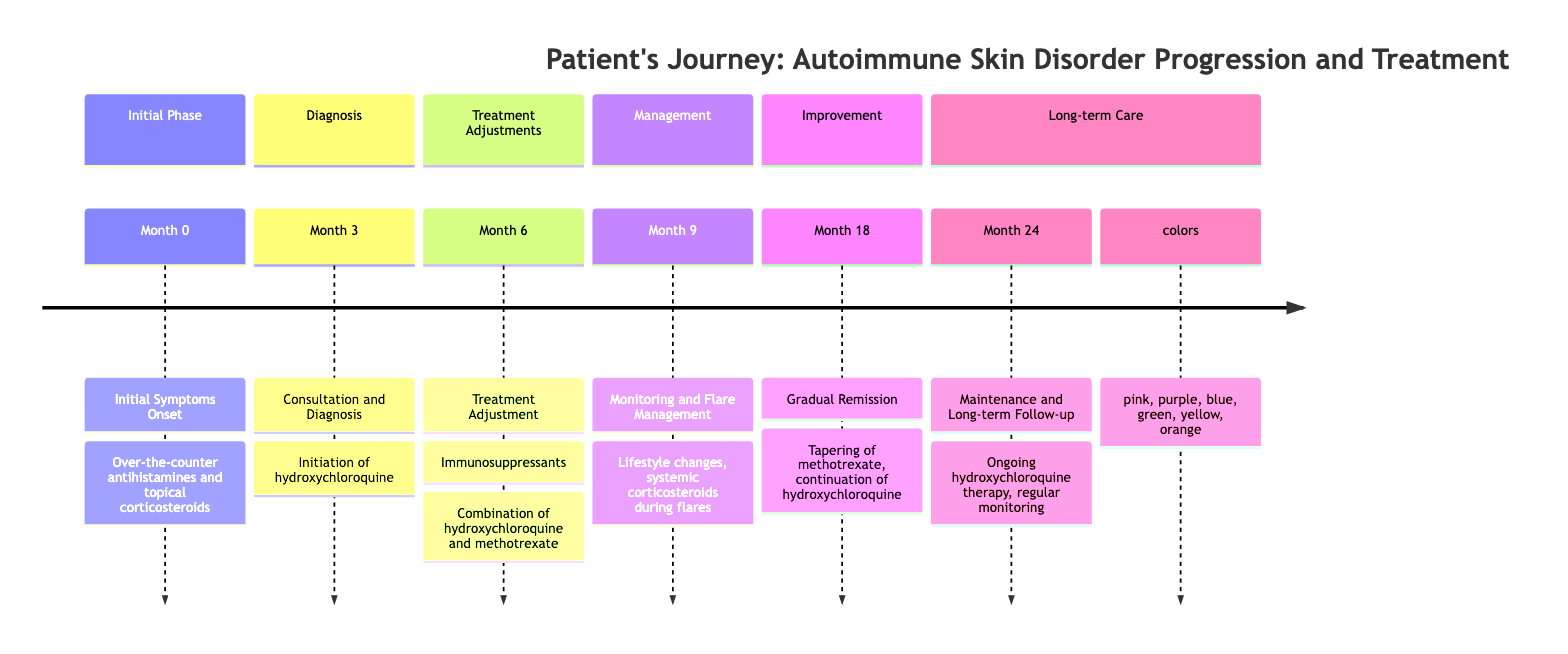What is the initial treatment for the patient? The patient initially received over-the-counter antihistamines and topical corticosteroids for symptom relief at the onset of symptoms. This information is mentioned in the "Initial Symptoms Onset" phase.
Answer: Over-the-counter antihistamines and topical corticosteroids How many months did it take for the patient to receive a diagnosis? The timeline indicates that the diagnosis occurred at Month 3, following the onset of symptoms at Month 0. Hence, the duration from initial symptoms to diagnosis is three months.
Answer: 3 months What medication was added at Month 6? At Month 6, methotrexate was prescribed in addition to the already ongoing hydroxychloroquine as part of the treatment adjustment phase. This is clearly outlined in the timeline.
Answer: Methotrexate What significant change occurred at Month 18? At Month 18, the patient experienced gradual remission, with significant improvement in their condition. This is a notable transition point focusing on the patient's health status.
Answer: Gradual remission What type of lifestyle changes were suggested at Month 9? The patient was advised to implement lifestyle changes, specifically wearing sunscreen and using stress management techniques to help control flare-ups and manage symptoms effectively, as stated in the "Monitoring and Flare Management" section.
Answer: Lifestyle changes How often did the patient have follow-up appointments at Month 24? The timeline notes that the patient had regular follow-up appointments scheduled every 6 months at Month 24 as part of ongoing maintenance care.
Answer: Every 6 months What was the treatment plan at Month 24? At Month 24, the ongoing treatment plan included hydroxychloroquine therapy, with regular monitoring of blood markers and maintenance of lifestyle adjustments that had been previously recommended. This encapsulates the long-term care strategy.
Answer: Ongoing hydroxychloroquine therapy How long did the patient remain in clinical remission? The timeline specifies that the patient was in clinical remission at Month 24, thus indicating they had remained in this state for a period from Month 18 to Month 24, amounting to a duration of 6 months.
Answer: 6 months What monitoring was conducted at Month 9? At Month 9, the monitoring included watching symptoms and blood markers for disease activity, along with the identification of triggers related to the patient's condition. This assessment is crucial for managing autoimmune skin disorders effectively.
Answer: Symptoms and blood markers monitoring 